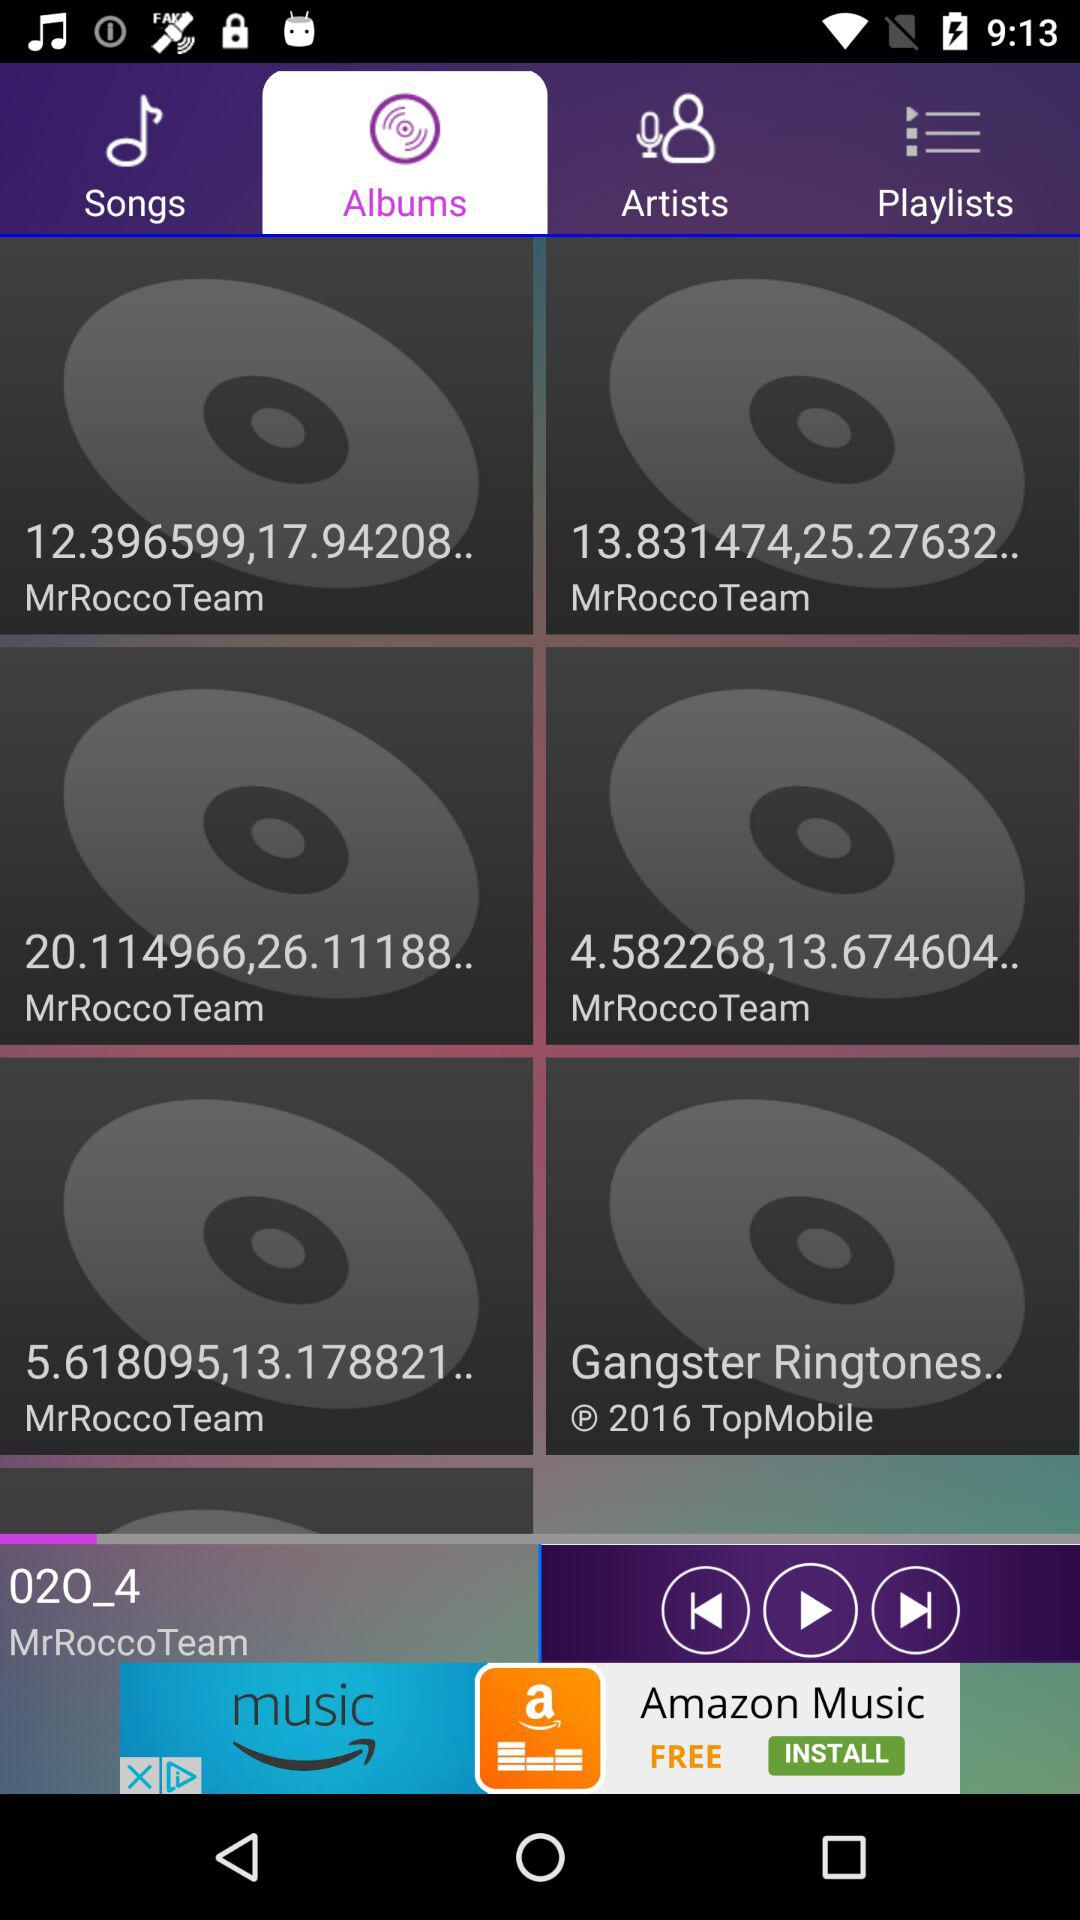Which is the selected tab? The selected tab is "Albums". 